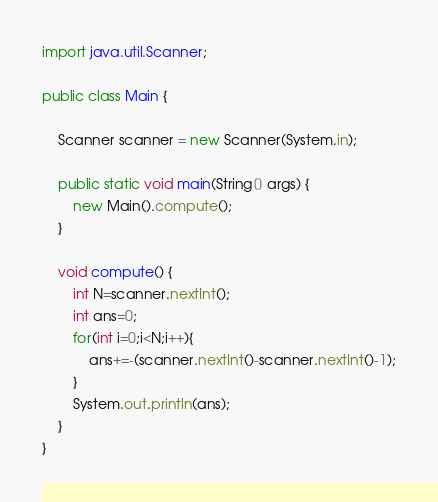<code> <loc_0><loc_0><loc_500><loc_500><_Java_>import java.util.Scanner;
 
public class Main {
 
    Scanner scanner = new Scanner(System.in);
 
    public static void main(String[] args) {
        new Main().compute();
    }
 
    void compute() {
        int N=scanner.nextInt();
        int ans=0;
        for(int i=0;i<N;i++){
            ans+=-(scanner.nextInt()-scanner.nextInt()-1);
        }
        System.out.println(ans);
    }
}</code> 